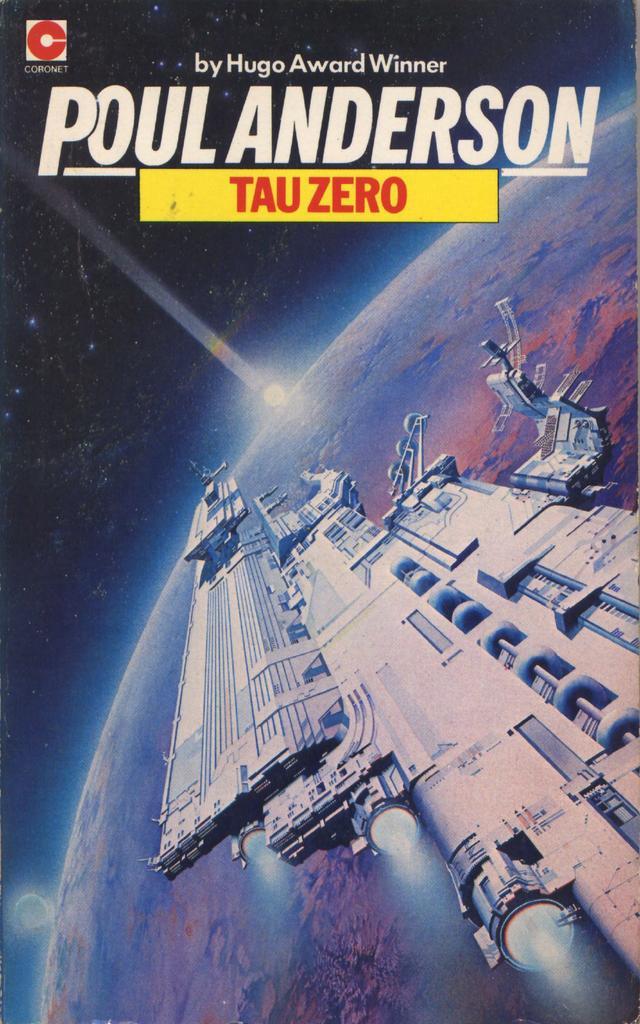Describe this image in one or two sentences. In this image we can see a poster, it looks like a satellite, there is a planet, there is a light, there is some matter written on the top. 